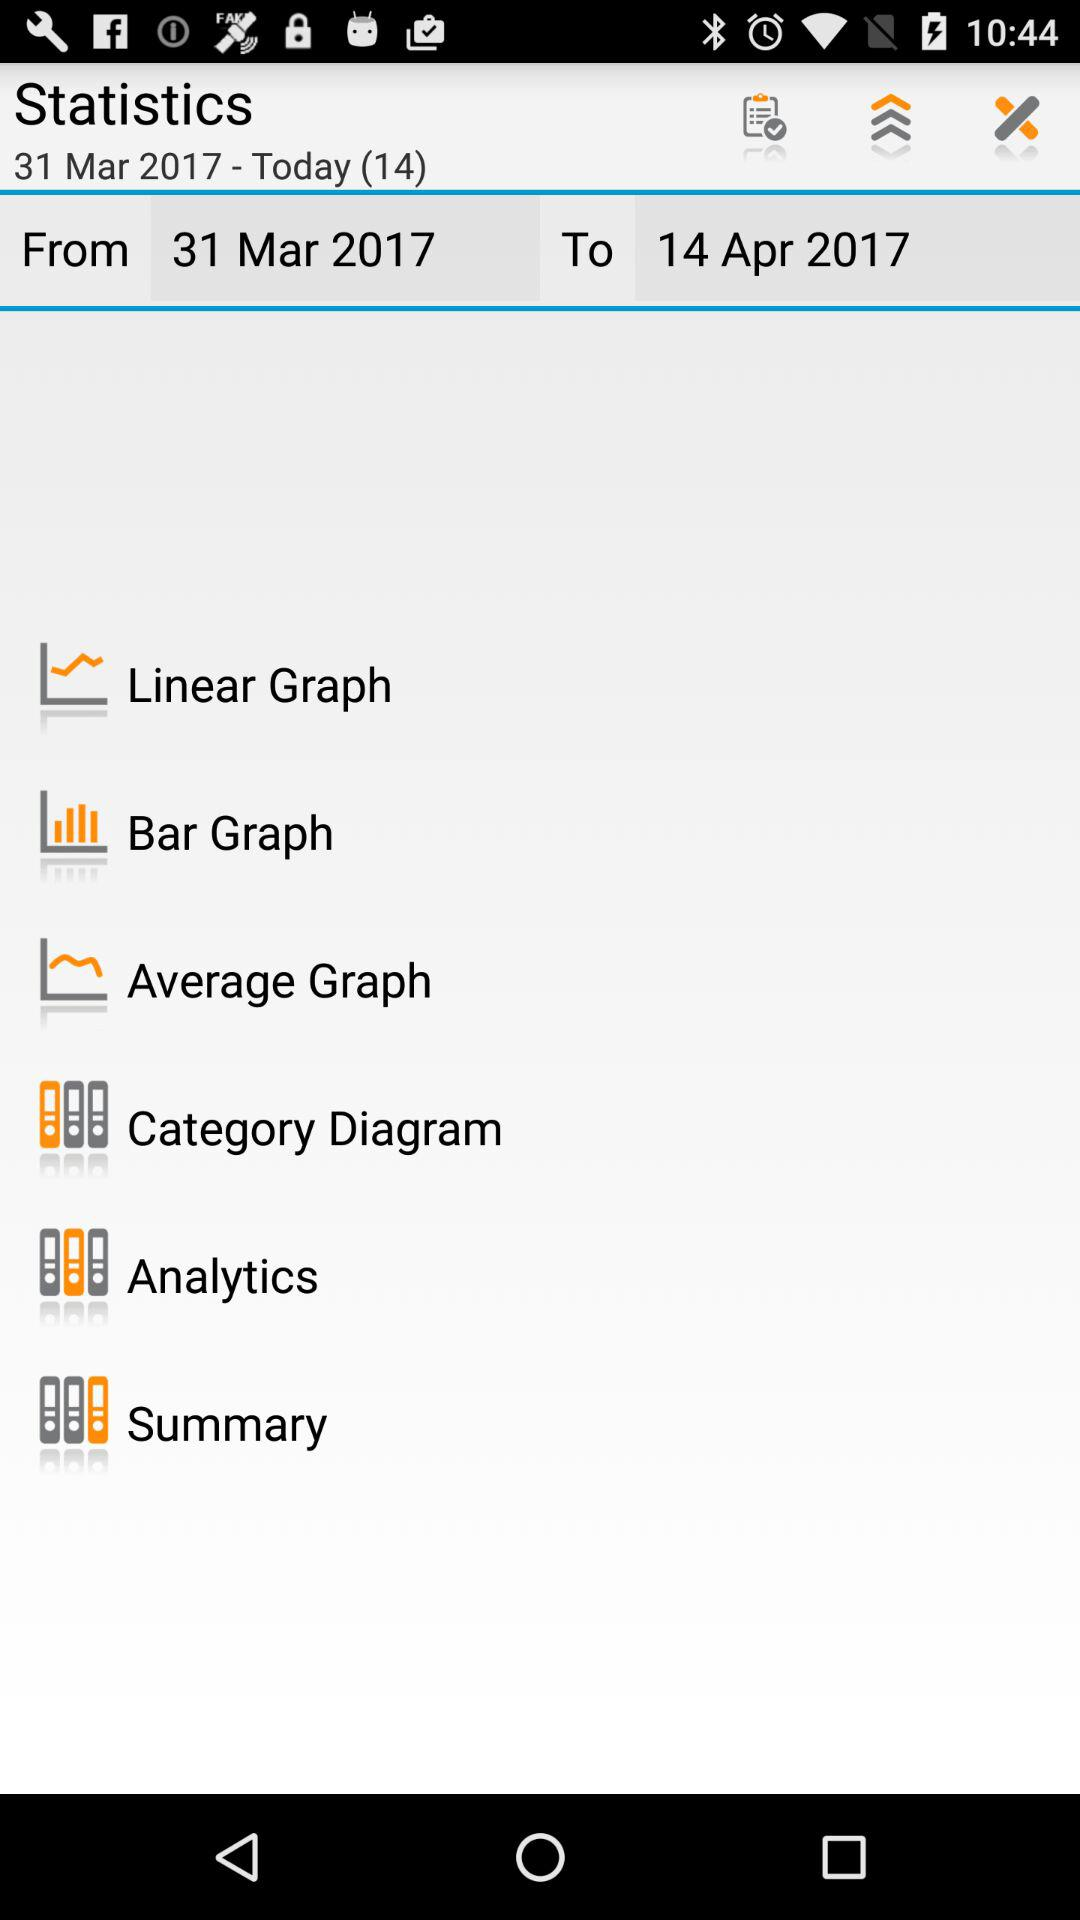What is the date today? The date is March 31, 2017. 